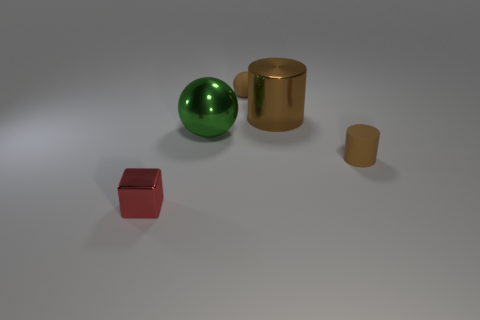Add 5 small gray objects. How many objects exist? 10 Subtract all spheres. How many objects are left? 3 Subtract all tiny red shiny cylinders. Subtract all tiny rubber things. How many objects are left? 3 Add 2 big brown metallic cylinders. How many big brown metallic cylinders are left? 3 Add 3 red things. How many red things exist? 4 Subtract 1 red blocks. How many objects are left? 4 